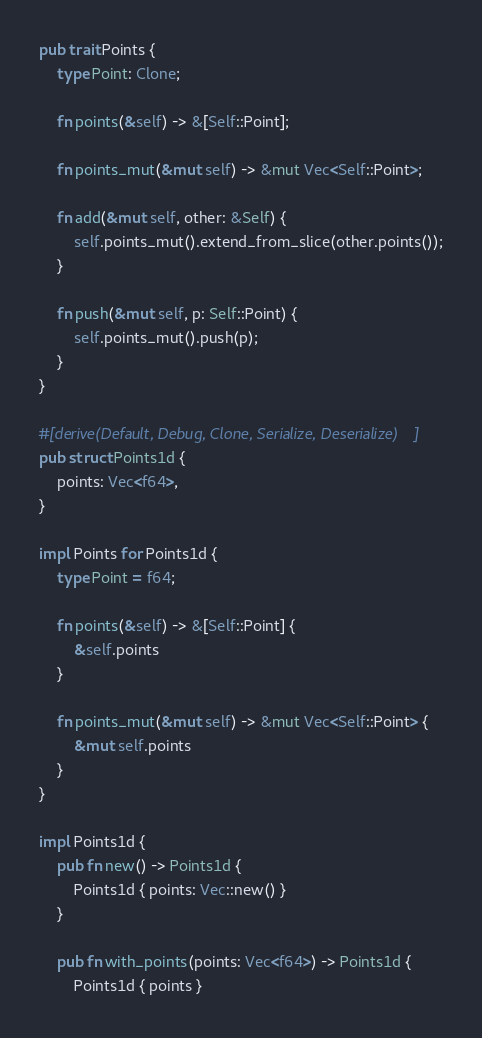<code> <loc_0><loc_0><loc_500><loc_500><_Rust_>pub trait Points {
    type Point: Clone;

    fn points(&self) -> &[Self::Point];

    fn points_mut(&mut self) -> &mut Vec<Self::Point>;

    fn add(&mut self, other: &Self) {
        self.points_mut().extend_from_slice(other.points());
    }

    fn push(&mut self, p: Self::Point) {
        self.points_mut().push(p);
    }
}

#[derive(Default, Debug, Clone, Serialize, Deserialize)]
pub struct Points1d {
    points: Vec<f64>,
}

impl Points for Points1d {
    type Point = f64;

    fn points(&self) -> &[Self::Point] {
        &self.points
    }

    fn points_mut(&mut self) -> &mut Vec<Self::Point> {
        &mut self.points
    }
}

impl Points1d {
    pub fn new() -> Points1d {
        Points1d { points: Vec::new() }
    }

    pub fn with_points(points: Vec<f64>) -> Points1d {
        Points1d { points }</code> 